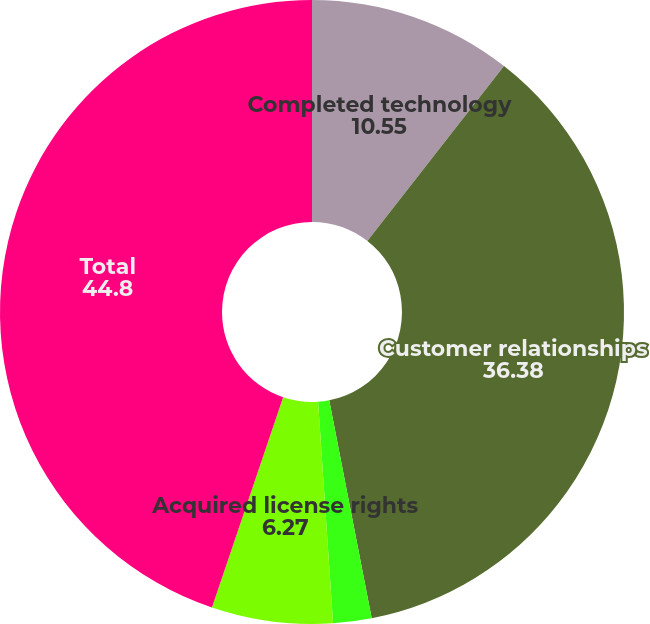<chart> <loc_0><loc_0><loc_500><loc_500><pie_chart><fcel>Completed technology<fcel>Customer relationships<fcel>Non-compete agreements<fcel>Acquired license rights<fcel>Total<nl><fcel>10.55%<fcel>36.38%<fcel>1.99%<fcel>6.27%<fcel>44.8%<nl></chart> 